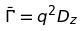<formula> <loc_0><loc_0><loc_500><loc_500>\ { \bar { \Gamma } } = q ^ { 2 } D _ { z }</formula> 